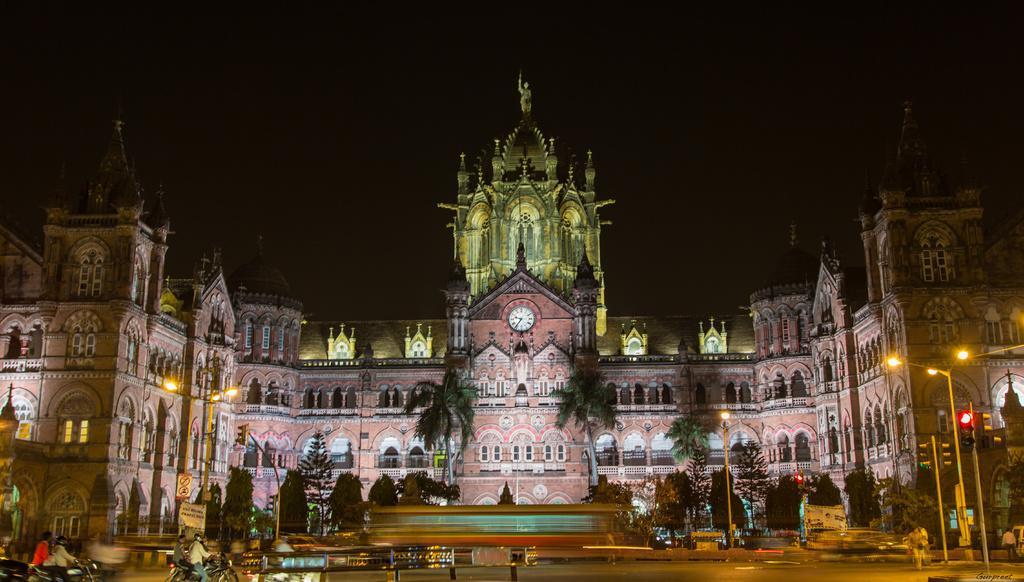How would you summarize this image in a sentence or two? At the bottom of the image there are some vehicles on the road and few people are riding motorcycle and few people are walking. Behind them there are some poles and trees. In the middle of the image we can see a building. 